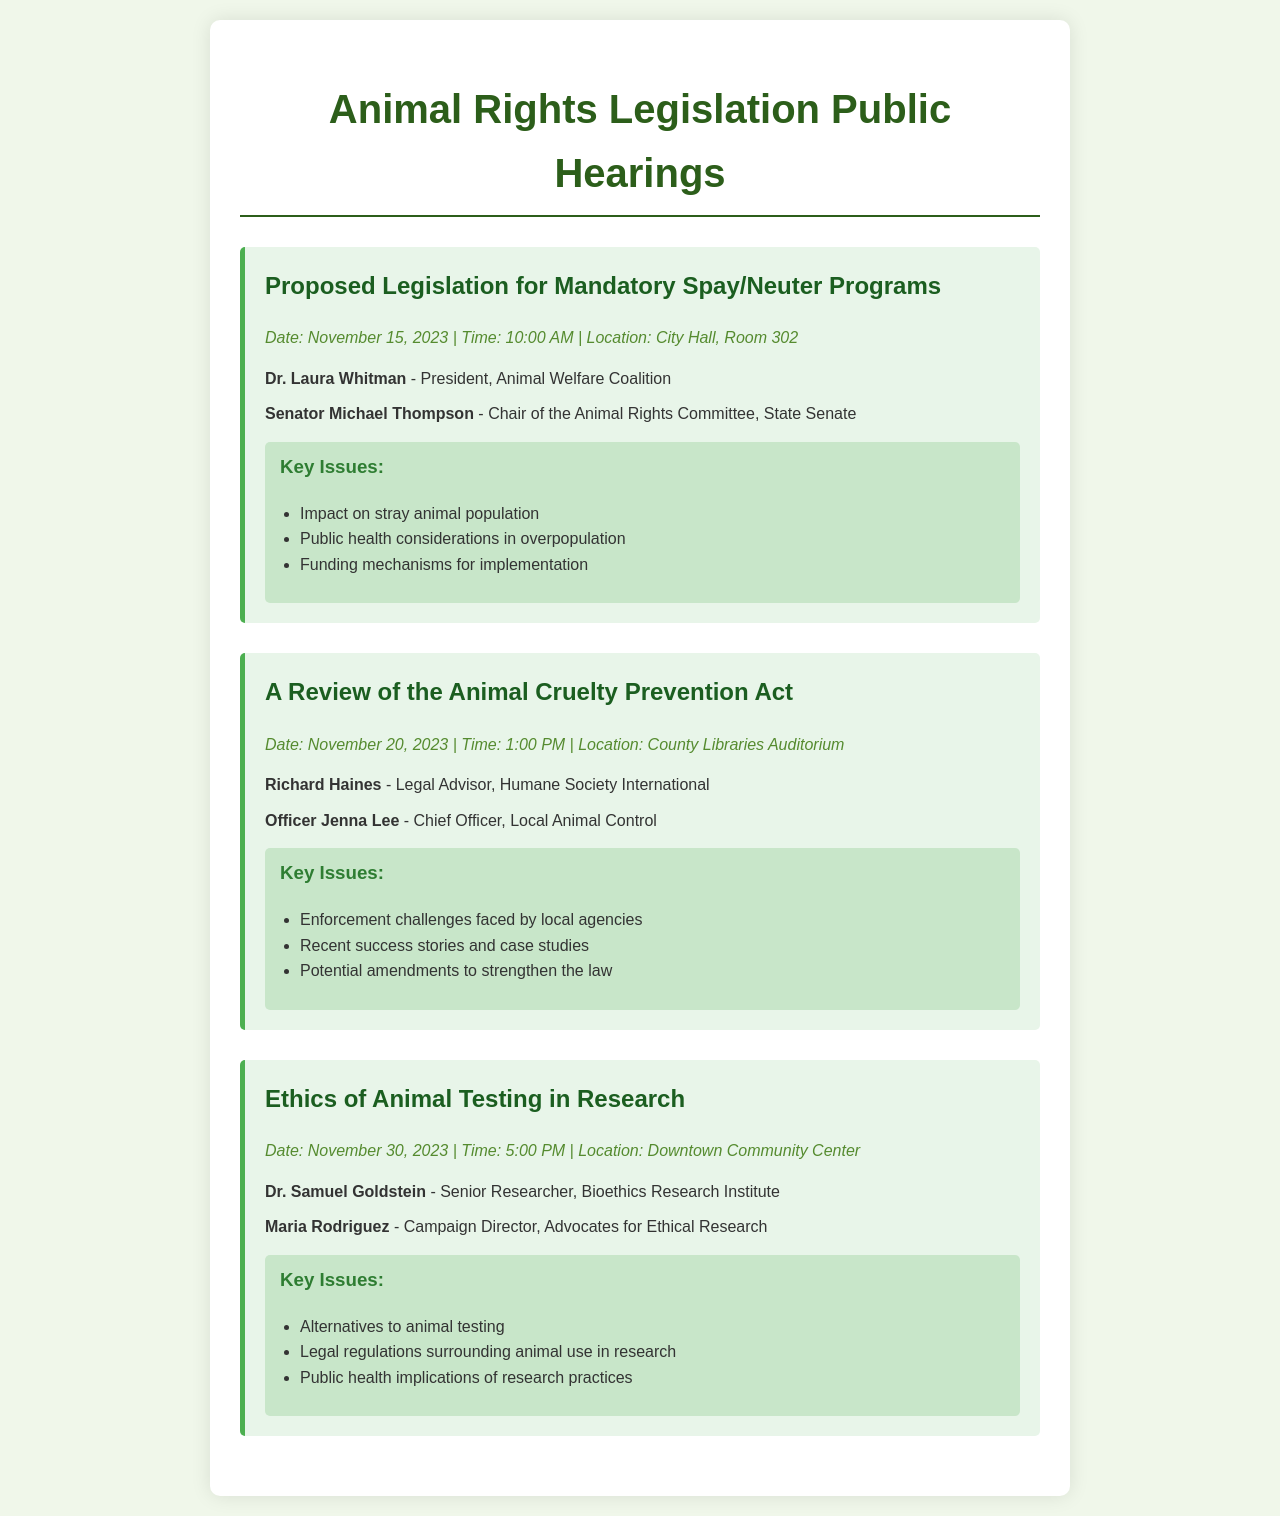What is the date of the hearing on mandatory spay/neuter programs? The date for the hearing on mandatory spay/neuter programs can be found in the document, which states it is on November 15, 2023.
Answer: November 15, 2023 Who is the speaker from the Animal Welfare Coalition? The speaker from the Animal Welfare Coalition is listed in the document as Dr. Laura Whitman.
Answer: Dr. Laura Whitman What is one of the key issues addressed in the Animal Cruelty Prevention Act review? The document lists several key issues for the review of the Animal Cruelty Prevention Act, one of which is "Enforcement challenges faced by local agencies."
Answer: Enforcement challenges faced by local agencies What time does the hearing on the ethics of animal testing start? The hearing on the ethics of animal testing starts at the time specified in the document, which is 5:00 PM.
Answer: 5:00 PM Who is the Chief Officer from Local Animal Control speaking at the November 20 hearing? The document provides the name of the Chief Officer from Local Animal Control, which is Officer Jenna Lee.
Answer: Officer Jenna Lee What is the location for the hearing about ethics in animal testing? The location for the hearing about ethics in animal testing is found in the document; it states it will be at the Downtown Community Center.
Answer: Downtown Community Center 